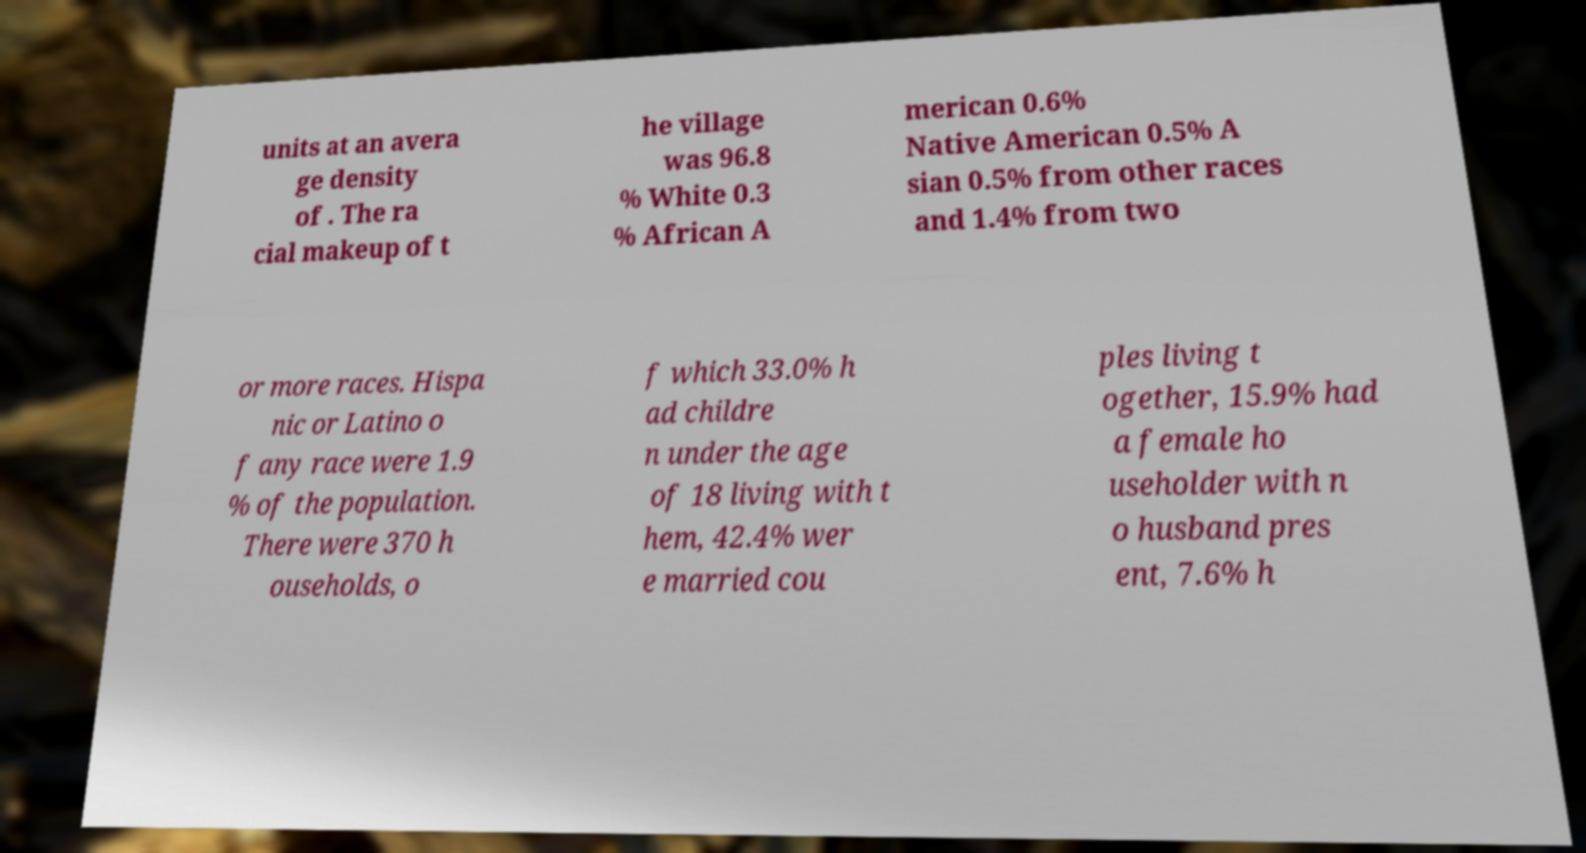Can you accurately transcribe the text from the provided image for me? units at an avera ge density of . The ra cial makeup of t he village was 96.8 % White 0.3 % African A merican 0.6% Native American 0.5% A sian 0.5% from other races and 1.4% from two or more races. Hispa nic or Latino o f any race were 1.9 % of the population. There were 370 h ouseholds, o f which 33.0% h ad childre n under the age of 18 living with t hem, 42.4% wer e married cou ples living t ogether, 15.9% had a female ho useholder with n o husband pres ent, 7.6% h 